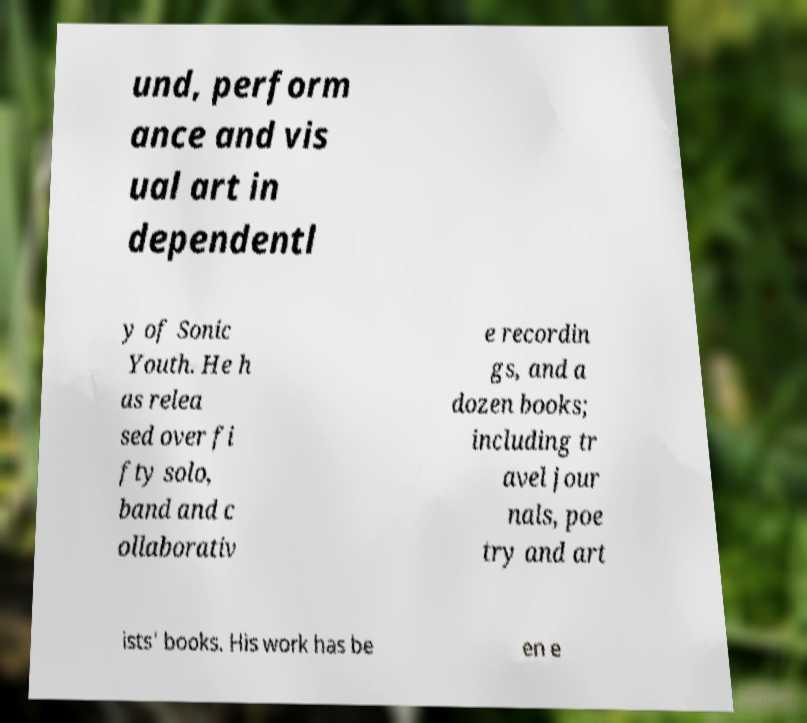Can you accurately transcribe the text from the provided image for me? und, perform ance and vis ual art in dependentl y of Sonic Youth. He h as relea sed over fi fty solo, band and c ollaborativ e recordin gs, and a dozen books; including tr avel jour nals, poe try and art ists' books. His work has be en e 